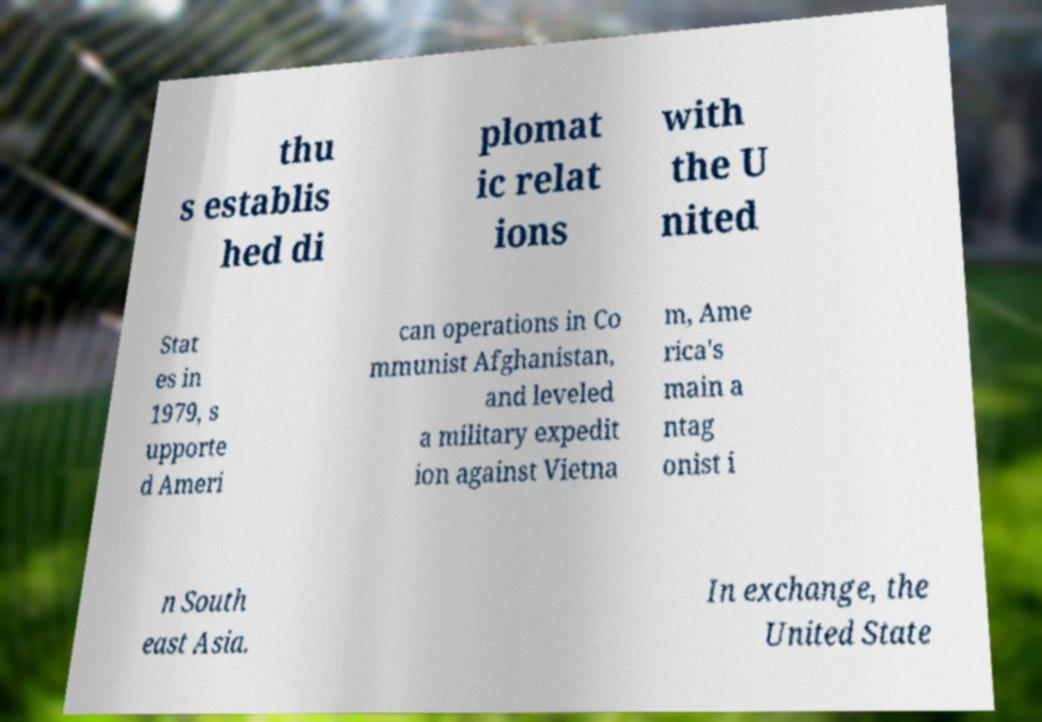Please identify and transcribe the text found in this image. thu s establis hed di plomat ic relat ions with the U nited Stat es in 1979, s upporte d Ameri can operations in Co mmunist Afghanistan, and leveled a military expedit ion against Vietna m, Ame rica's main a ntag onist i n South east Asia. In exchange, the United State 